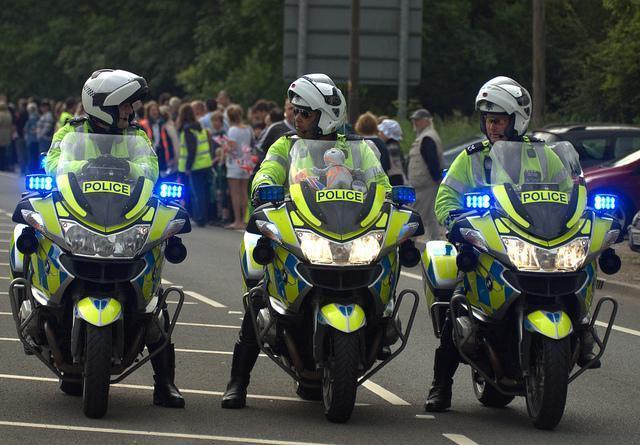How many riders are shown?
Give a very brief answer. 3. How many motorcycles are visible?
Give a very brief answer. 3. How many people are there?
Give a very brief answer. 7. 